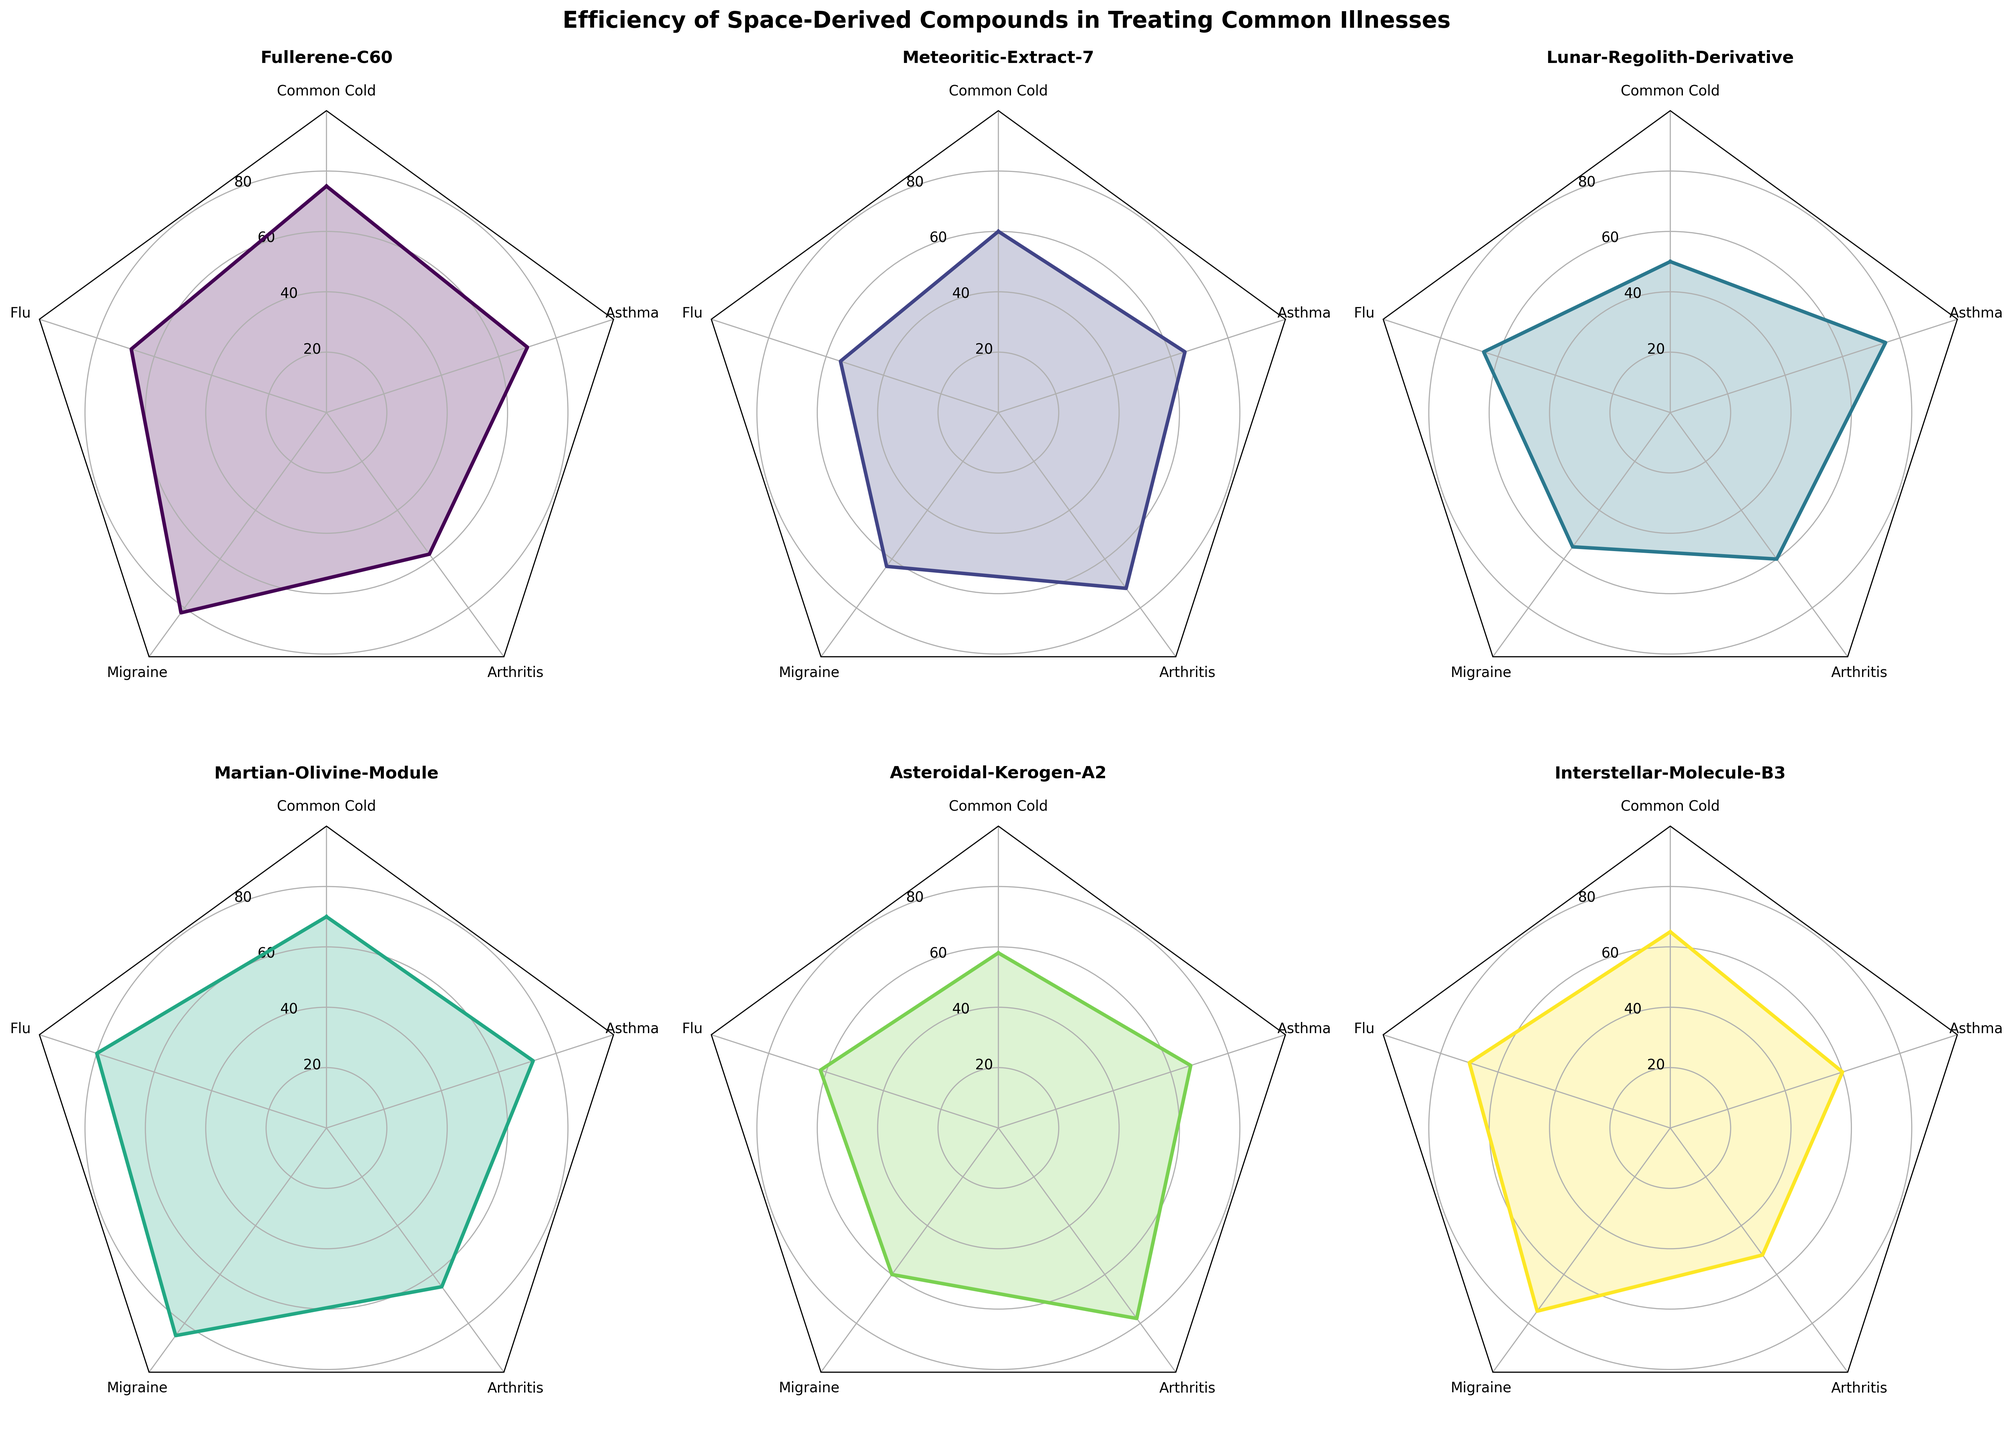What is the title of the entire figure? The title is usually found at the top of the figure and provides an overall description of it. In this case, the title is located above the radar charts.
Answer: Efficiency of Space-Derived Compounds in Treating Common Illnesses What is the highest efficiency value achieved by Fullerene-C60, and for which illness? By examining the radar chart for Fullerene-C60, you can see which spoke extends the furthest from the center. This corresponds to the highest value.
Answer: 82 for Migraine Which compound shows the highest efficiency in treating the flu? To determine this, look at the flu spoke (labelled for flu) in each radar chart and find the one that extends the furthest from the center.
Answer: Martian-Olivine-Module Among the compounds, which one has the least effective treatment for arthritis? This requires checking the arthritis spoke on each radar chart and noting which compound has the shortest spoke for arthritis.
Answer: Interstellar-Molecule-B3 Compare the efficiency of Martian-Olivine-Module and Interstellar-Molecule-B3 in treating common cold and state which one is more efficient. Look at the common cold spoke for both Martian-Olivine-Module and Interstellar-Molecule-B3 and compare their lengths. Martian-Olivine-Module has a higher value.
Answer: Martian-Olivine-Module Calculate the average efficiency of Asteroidal-Kerogen-A2 across all illnesses. Sum the values for Asteroidal-Kerogen-A2 across all illnesses (58 + 62 + 60 + 78 + 67) and divide by the number of illnesses (5).
Answer: (58 + 62 + 60 + 78 + 67) / 5 = 65 Which compound has the most balanced performance across all illnesses (meaning the smallest range between its maximum and minimum values)? For each compound, find the range (difference between max and min values). The compound with the smallest range is the most balanced.
Answer: Lunar-Regolith-Derivative (75 - 50 = 25) Between the common cold and asthma, which illness is treated with higher efficiency by Lunar-Regolith-Derivative? Check the radar chart for Lunar-Regolith-Derivative and compare the spoke lengths for common cold and asthma. Asthma has a higher value.
Answer: Asthma Which compound has the lowest efficiency score for any illness, and what is that score? Examine all the spokes on all the radar charts and identify the shortest spoke. The shortest spoke on the entire figure corresponds to the lowest efficiency score.
Answer: Interstellar-Molecule-B3 for Arthritis with a value of 52 Rank the compounds based on their efficiency in treating migraines from least to most efficient. Check the migraines spoke on each radar chart and list the values, then sort them in ascending order.
Answer: Lunar-Regolith-Derivative, Asteroidal-Kerogen-A2, Meteoritic-Extract-7, Interstellar-Molecule-B3, Fullerene-C60, Martian-Olivine-Module 